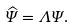<formula> <loc_0><loc_0><loc_500><loc_500>\widehat { \Psi } = \Lambda \Psi .</formula> 